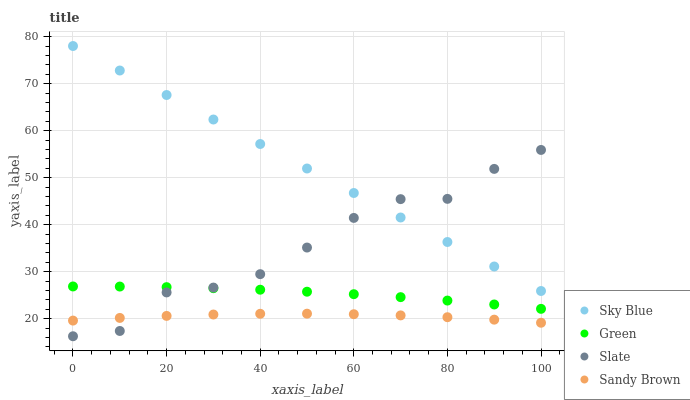Does Sandy Brown have the minimum area under the curve?
Answer yes or no. Yes. Does Sky Blue have the maximum area under the curve?
Answer yes or no. Yes. Does Slate have the minimum area under the curve?
Answer yes or no. No. Does Slate have the maximum area under the curve?
Answer yes or no. No. Is Sky Blue the smoothest?
Answer yes or no. Yes. Is Slate the roughest?
Answer yes or no. Yes. Is Green the smoothest?
Answer yes or no. No. Is Green the roughest?
Answer yes or no. No. Does Slate have the lowest value?
Answer yes or no. Yes. Does Green have the lowest value?
Answer yes or no. No. Does Sky Blue have the highest value?
Answer yes or no. Yes. Does Slate have the highest value?
Answer yes or no. No. Is Sandy Brown less than Sky Blue?
Answer yes or no. Yes. Is Sky Blue greater than Sandy Brown?
Answer yes or no. Yes. Does Slate intersect Sandy Brown?
Answer yes or no. Yes. Is Slate less than Sandy Brown?
Answer yes or no. No. Is Slate greater than Sandy Brown?
Answer yes or no. No. Does Sandy Brown intersect Sky Blue?
Answer yes or no. No. 